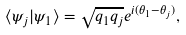<formula> <loc_0><loc_0><loc_500><loc_500>\langle \psi _ { j } | \psi _ { 1 } \rangle = \sqrt { q _ { 1 } q _ { j } } e ^ { i ( \theta _ { 1 } - \theta _ { j } ) } ,</formula> 